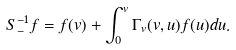<formula> <loc_0><loc_0><loc_500><loc_500>S _ { - } ^ { - 1 } f = f ( v ) + \int _ { 0 } ^ { v } \Gamma _ { v } ( v , u ) f ( u ) d u .</formula> 